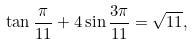<formula> <loc_0><loc_0><loc_500><loc_500>\tan \frac { \pi } { 1 1 } + 4 \sin \frac { 3 \pi } { 1 1 } = \sqrt { 1 1 } ,</formula> 